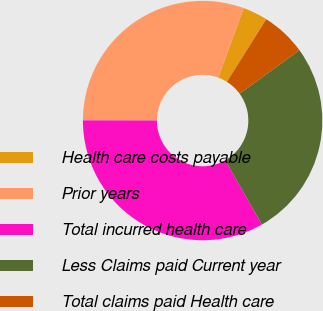Convert chart to OTSL. <chart><loc_0><loc_0><loc_500><loc_500><pie_chart><fcel>Health care costs payable<fcel>Prior years<fcel>Total incurred health care<fcel>Less Claims paid Current year<fcel>Total claims paid Health care<nl><fcel>3.35%<fcel>30.54%<fcel>33.27%<fcel>26.77%<fcel>6.07%<nl></chart> 